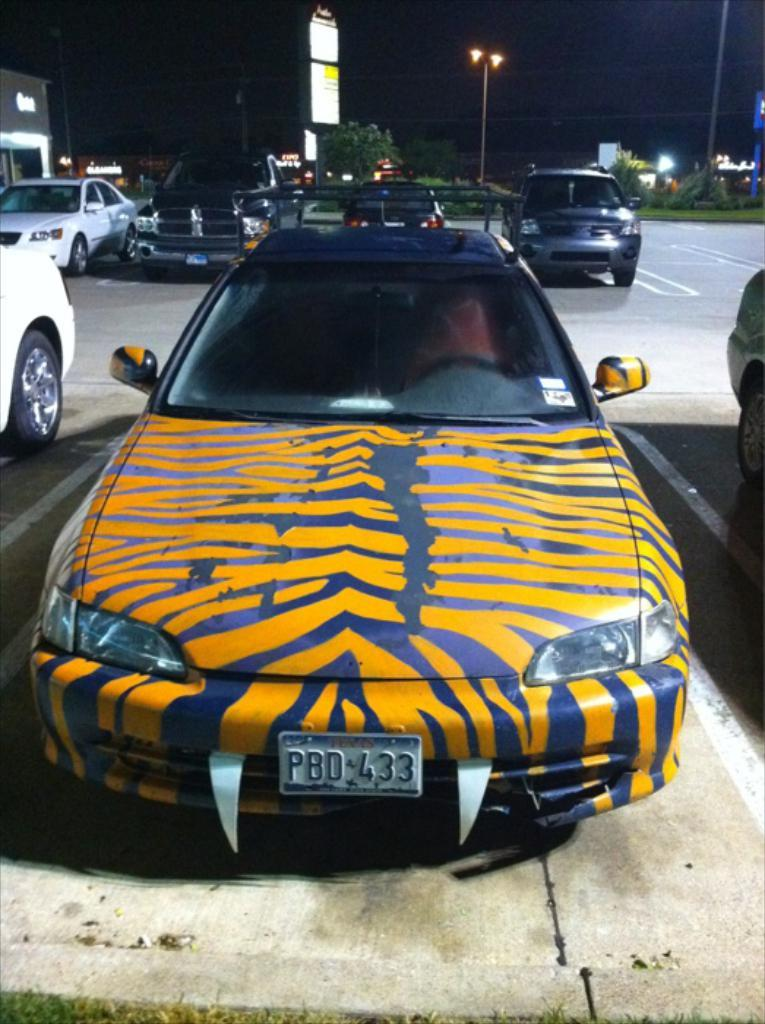<image>
Offer a succinct explanation of the picture presented. A car has orange stripes and the license plate says Texas. 